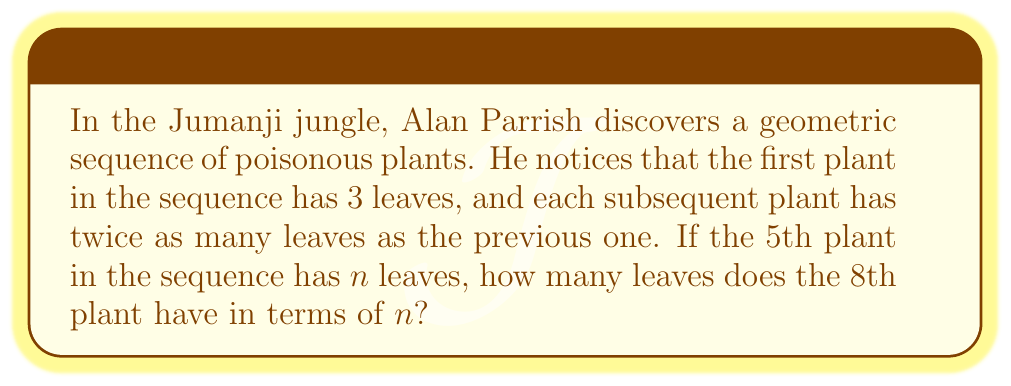Solve this math problem. Let's approach this step-by-step:

1) In a geometric sequence, each term is found by multiplying the previous term by a constant, called the common ratio. Here, the common ratio is 2.

2) We can represent the sequence as:
   $a_1, a_1r, a_1r^2, a_1r^3, ...$
   where $a_1$ is the first term and $r$ is the common ratio.

3) We're told that $a_1 = 3$ and $r = 2$.

4) The 5th term in the sequence is given as $n$. We can express this as:
   $n = a_1r^4 = 3 \cdot 2^4 = 3 \cdot 16 = 48$

5) Now, we need to find the 8th term. We can express this as:
   $a_8 = a_1r^7 = 3 \cdot 2^7$

6) We want to express this in terms of $n$. We know that $n = 3 \cdot 2^4$, so:
   $2^4 = \frac{n}{3}$

7) Therefore:
   $a_8 = 3 \cdot 2^7 = 3 \cdot 2^3 \cdot 2^4 = 3 \cdot 8 \cdot \frac{n}{3} = 8n$

Thus, the 8th plant has $8n$ leaves.
Answer: $8n$ leaves 